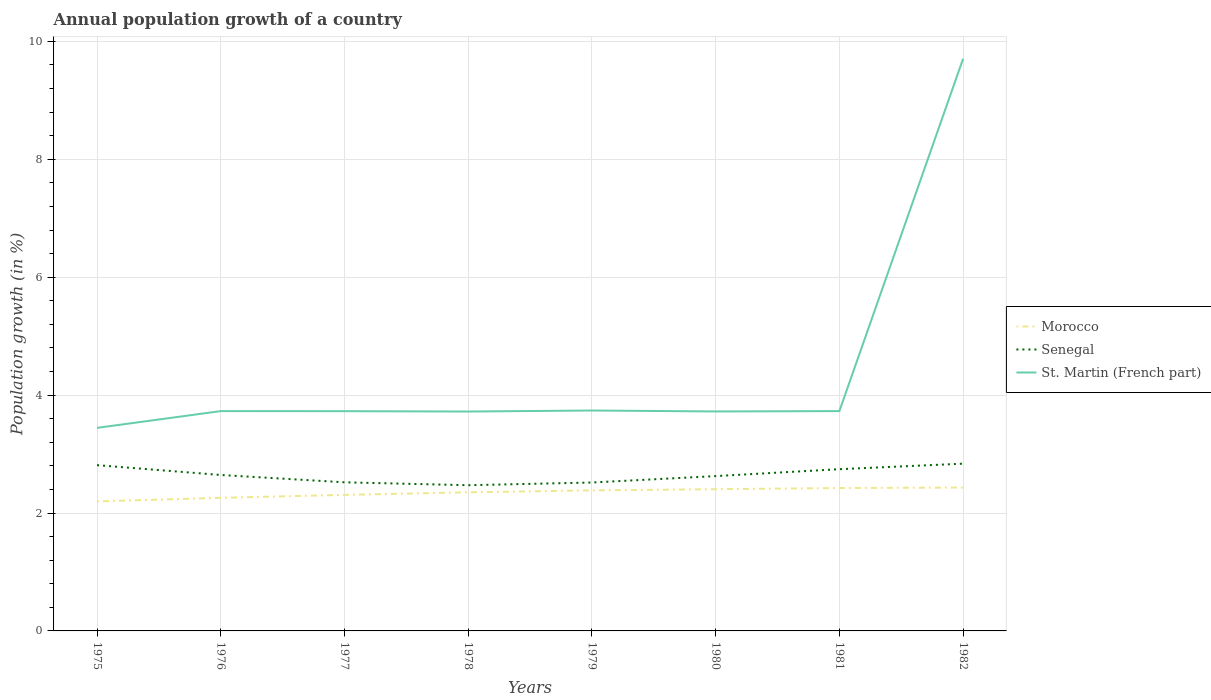How many different coloured lines are there?
Your answer should be compact. 3. Is the number of lines equal to the number of legend labels?
Your answer should be compact. Yes. Across all years, what is the maximum annual population growth in Senegal?
Ensure brevity in your answer.  2.47. In which year was the annual population growth in Senegal maximum?
Offer a very short reply. 1978. What is the total annual population growth in Senegal in the graph?
Your response must be concise. -0.21. What is the difference between the highest and the second highest annual population growth in Morocco?
Offer a terse response. 0.24. Is the annual population growth in St. Martin (French part) strictly greater than the annual population growth in Senegal over the years?
Offer a very short reply. No. How many years are there in the graph?
Offer a terse response. 8. Does the graph contain any zero values?
Keep it short and to the point. No. Does the graph contain grids?
Give a very brief answer. Yes. Where does the legend appear in the graph?
Give a very brief answer. Center right. How many legend labels are there?
Provide a short and direct response. 3. What is the title of the graph?
Offer a terse response. Annual population growth of a country. What is the label or title of the Y-axis?
Your response must be concise. Population growth (in %). What is the Population growth (in %) of Morocco in 1975?
Offer a very short reply. 2.2. What is the Population growth (in %) in Senegal in 1975?
Ensure brevity in your answer.  2.81. What is the Population growth (in %) in St. Martin (French part) in 1975?
Your answer should be very brief. 3.44. What is the Population growth (in %) of Morocco in 1976?
Provide a short and direct response. 2.26. What is the Population growth (in %) of Senegal in 1976?
Ensure brevity in your answer.  2.65. What is the Population growth (in %) of St. Martin (French part) in 1976?
Keep it short and to the point. 3.73. What is the Population growth (in %) of Morocco in 1977?
Your answer should be compact. 2.31. What is the Population growth (in %) in Senegal in 1977?
Offer a very short reply. 2.52. What is the Population growth (in %) in St. Martin (French part) in 1977?
Your answer should be very brief. 3.73. What is the Population growth (in %) of Morocco in 1978?
Ensure brevity in your answer.  2.35. What is the Population growth (in %) of Senegal in 1978?
Provide a short and direct response. 2.47. What is the Population growth (in %) in St. Martin (French part) in 1978?
Your response must be concise. 3.72. What is the Population growth (in %) of Morocco in 1979?
Your answer should be compact. 2.38. What is the Population growth (in %) in Senegal in 1979?
Provide a succinct answer. 2.52. What is the Population growth (in %) of St. Martin (French part) in 1979?
Offer a terse response. 3.74. What is the Population growth (in %) of Morocco in 1980?
Provide a short and direct response. 2.4. What is the Population growth (in %) in Senegal in 1980?
Ensure brevity in your answer.  2.63. What is the Population growth (in %) of St. Martin (French part) in 1980?
Keep it short and to the point. 3.72. What is the Population growth (in %) of Morocco in 1981?
Your response must be concise. 2.42. What is the Population growth (in %) in Senegal in 1981?
Keep it short and to the point. 2.74. What is the Population growth (in %) in St. Martin (French part) in 1981?
Provide a short and direct response. 3.73. What is the Population growth (in %) of Morocco in 1982?
Your response must be concise. 2.43. What is the Population growth (in %) of Senegal in 1982?
Your response must be concise. 2.84. What is the Population growth (in %) of St. Martin (French part) in 1982?
Provide a short and direct response. 9.71. Across all years, what is the maximum Population growth (in %) in Morocco?
Give a very brief answer. 2.43. Across all years, what is the maximum Population growth (in %) of Senegal?
Provide a succinct answer. 2.84. Across all years, what is the maximum Population growth (in %) in St. Martin (French part)?
Your answer should be very brief. 9.71. Across all years, what is the minimum Population growth (in %) of Morocco?
Ensure brevity in your answer.  2.2. Across all years, what is the minimum Population growth (in %) of Senegal?
Offer a terse response. 2.47. Across all years, what is the minimum Population growth (in %) in St. Martin (French part)?
Ensure brevity in your answer.  3.44. What is the total Population growth (in %) of Morocco in the graph?
Your answer should be compact. 18.76. What is the total Population growth (in %) of Senegal in the graph?
Offer a terse response. 21.17. What is the total Population growth (in %) of St. Martin (French part) in the graph?
Provide a short and direct response. 35.52. What is the difference between the Population growth (in %) of Morocco in 1975 and that in 1976?
Give a very brief answer. -0.06. What is the difference between the Population growth (in %) in Senegal in 1975 and that in 1976?
Your answer should be very brief. 0.17. What is the difference between the Population growth (in %) of St. Martin (French part) in 1975 and that in 1976?
Make the answer very short. -0.28. What is the difference between the Population growth (in %) of Morocco in 1975 and that in 1977?
Your answer should be very brief. -0.11. What is the difference between the Population growth (in %) of Senegal in 1975 and that in 1977?
Your response must be concise. 0.29. What is the difference between the Population growth (in %) in St. Martin (French part) in 1975 and that in 1977?
Make the answer very short. -0.28. What is the difference between the Population growth (in %) of Morocco in 1975 and that in 1978?
Your answer should be very brief. -0.15. What is the difference between the Population growth (in %) of Senegal in 1975 and that in 1978?
Give a very brief answer. 0.34. What is the difference between the Population growth (in %) of St. Martin (French part) in 1975 and that in 1978?
Make the answer very short. -0.28. What is the difference between the Population growth (in %) of Morocco in 1975 and that in 1979?
Offer a terse response. -0.19. What is the difference between the Population growth (in %) of Senegal in 1975 and that in 1979?
Your answer should be compact. 0.29. What is the difference between the Population growth (in %) in St. Martin (French part) in 1975 and that in 1979?
Provide a succinct answer. -0.29. What is the difference between the Population growth (in %) in Morocco in 1975 and that in 1980?
Provide a succinct answer. -0.21. What is the difference between the Population growth (in %) in Senegal in 1975 and that in 1980?
Your answer should be compact. 0.19. What is the difference between the Population growth (in %) of St. Martin (French part) in 1975 and that in 1980?
Offer a very short reply. -0.28. What is the difference between the Population growth (in %) of Morocco in 1975 and that in 1981?
Offer a very short reply. -0.23. What is the difference between the Population growth (in %) in Senegal in 1975 and that in 1981?
Your answer should be very brief. 0.07. What is the difference between the Population growth (in %) in St. Martin (French part) in 1975 and that in 1981?
Offer a terse response. -0.28. What is the difference between the Population growth (in %) in Morocco in 1975 and that in 1982?
Your answer should be very brief. -0.23. What is the difference between the Population growth (in %) of Senegal in 1975 and that in 1982?
Offer a very short reply. -0.03. What is the difference between the Population growth (in %) in St. Martin (French part) in 1975 and that in 1982?
Provide a short and direct response. -6.26. What is the difference between the Population growth (in %) of Morocco in 1976 and that in 1977?
Your response must be concise. -0.05. What is the difference between the Population growth (in %) in Senegal in 1976 and that in 1977?
Your answer should be very brief. 0.12. What is the difference between the Population growth (in %) in St. Martin (French part) in 1976 and that in 1977?
Offer a very short reply. 0. What is the difference between the Population growth (in %) of Morocco in 1976 and that in 1978?
Your answer should be compact. -0.09. What is the difference between the Population growth (in %) of Senegal in 1976 and that in 1978?
Provide a succinct answer. 0.17. What is the difference between the Population growth (in %) in St. Martin (French part) in 1976 and that in 1978?
Keep it short and to the point. 0.01. What is the difference between the Population growth (in %) in Morocco in 1976 and that in 1979?
Give a very brief answer. -0.13. What is the difference between the Population growth (in %) in Senegal in 1976 and that in 1979?
Offer a terse response. 0.13. What is the difference between the Population growth (in %) in St. Martin (French part) in 1976 and that in 1979?
Provide a succinct answer. -0.01. What is the difference between the Population growth (in %) in Morocco in 1976 and that in 1980?
Give a very brief answer. -0.15. What is the difference between the Population growth (in %) of Senegal in 1976 and that in 1980?
Make the answer very short. 0.02. What is the difference between the Population growth (in %) of St. Martin (French part) in 1976 and that in 1980?
Your answer should be very brief. 0.01. What is the difference between the Population growth (in %) of Morocco in 1976 and that in 1981?
Provide a succinct answer. -0.17. What is the difference between the Population growth (in %) in Senegal in 1976 and that in 1981?
Offer a very short reply. -0.1. What is the difference between the Population growth (in %) of St. Martin (French part) in 1976 and that in 1981?
Your answer should be compact. -0. What is the difference between the Population growth (in %) in Morocco in 1976 and that in 1982?
Ensure brevity in your answer.  -0.17. What is the difference between the Population growth (in %) of Senegal in 1976 and that in 1982?
Keep it short and to the point. -0.19. What is the difference between the Population growth (in %) in St. Martin (French part) in 1976 and that in 1982?
Give a very brief answer. -5.98. What is the difference between the Population growth (in %) of Morocco in 1977 and that in 1978?
Your response must be concise. -0.04. What is the difference between the Population growth (in %) of Senegal in 1977 and that in 1978?
Give a very brief answer. 0.05. What is the difference between the Population growth (in %) of St. Martin (French part) in 1977 and that in 1978?
Your answer should be compact. 0.01. What is the difference between the Population growth (in %) of Morocco in 1977 and that in 1979?
Keep it short and to the point. -0.08. What is the difference between the Population growth (in %) in Senegal in 1977 and that in 1979?
Offer a very short reply. 0. What is the difference between the Population growth (in %) of St. Martin (French part) in 1977 and that in 1979?
Give a very brief answer. -0.01. What is the difference between the Population growth (in %) in Morocco in 1977 and that in 1980?
Ensure brevity in your answer.  -0.1. What is the difference between the Population growth (in %) in Senegal in 1977 and that in 1980?
Your answer should be very brief. -0.11. What is the difference between the Population growth (in %) in St. Martin (French part) in 1977 and that in 1980?
Make the answer very short. 0. What is the difference between the Population growth (in %) of Morocco in 1977 and that in 1981?
Ensure brevity in your answer.  -0.12. What is the difference between the Population growth (in %) of Senegal in 1977 and that in 1981?
Keep it short and to the point. -0.22. What is the difference between the Population growth (in %) in St. Martin (French part) in 1977 and that in 1981?
Offer a terse response. -0. What is the difference between the Population growth (in %) of Morocco in 1977 and that in 1982?
Your answer should be very brief. -0.12. What is the difference between the Population growth (in %) of Senegal in 1977 and that in 1982?
Keep it short and to the point. -0.32. What is the difference between the Population growth (in %) in St. Martin (French part) in 1977 and that in 1982?
Your answer should be very brief. -5.98. What is the difference between the Population growth (in %) of Morocco in 1978 and that in 1979?
Keep it short and to the point. -0.03. What is the difference between the Population growth (in %) of Senegal in 1978 and that in 1979?
Offer a very short reply. -0.05. What is the difference between the Population growth (in %) in St. Martin (French part) in 1978 and that in 1979?
Make the answer very short. -0.02. What is the difference between the Population growth (in %) in Morocco in 1978 and that in 1980?
Ensure brevity in your answer.  -0.05. What is the difference between the Population growth (in %) in Senegal in 1978 and that in 1980?
Offer a terse response. -0.15. What is the difference between the Population growth (in %) in St. Martin (French part) in 1978 and that in 1980?
Ensure brevity in your answer.  -0. What is the difference between the Population growth (in %) in Morocco in 1978 and that in 1981?
Your response must be concise. -0.07. What is the difference between the Population growth (in %) in Senegal in 1978 and that in 1981?
Keep it short and to the point. -0.27. What is the difference between the Population growth (in %) of St. Martin (French part) in 1978 and that in 1981?
Ensure brevity in your answer.  -0.01. What is the difference between the Population growth (in %) of Morocco in 1978 and that in 1982?
Keep it short and to the point. -0.08. What is the difference between the Population growth (in %) of Senegal in 1978 and that in 1982?
Your answer should be very brief. -0.37. What is the difference between the Population growth (in %) of St. Martin (French part) in 1978 and that in 1982?
Your answer should be compact. -5.98. What is the difference between the Population growth (in %) of Morocco in 1979 and that in 1980?
Offer a very short reply. -0.02. What is the difference between the Population growth (in %) of Senegal in 1979 and that in 1980?
Provide a succinct answer. -0.11. What is the difference between the Population growth (in %) of St. Martin (French part) in 1979 and that in 1980?
Ensure brevity in your answer.  0.02. What is the difference between the Population growth (in %) in Morocco in 1979 and that in 1981?
Provide a succinct answer. -0.04. What is the difference between the Population growth (in %) in Senegal in 1979 and that in 1981?
Provide a short and direct response. -0.23. What is the difference between the Population growth (in %) in St. Martin (French part) in 1979 and that in 1981?
Your answer should be very brief. 0.01. What is the difference between the Population growth (in %) in Morocco in 1979 and that in 1982?
Your answer should be compact. -0.05. What is the difference between the Population growth (in %) in Senegal in 1979 and that in 1982?
Provide a succinct answer. -0.32. What is the difference between the Population growth (in %) in St. Martin (French part) in 1979 and that in 1982?
Your answer should be very brief. -5.97. What is the difference between the Population growth (in %) of Morocco in 1980 and that in 1981?
Offer a terse response. -0.02. What is the difference between the Population growth (in %) of Senegal in 1980 and that in 1981?
Provide a succinct answer. -0.12. What is the difference between the Population growth (in %) in St. Martin (French part) in 1980 and that in 1981?
Ensure brevity in your answer.  -0.01. What is the difference between the Population growth (in %) in Morocco in 1980 and that in 1982?
Ensure brevity in your answer.  -0.03. What is the difference between the Population growth (in %) in Senegal in 1980 and that in 1982?
Offer a very short reply. -0.21. What is the difference between the Population growth (in %) in St. Martin (French part) in 1980 and that in 1982?
Offer a terse response. -5.98. What is the difference between the Population growth (in %) of Morocco in 1981 and that in 1982?
Make the answer very short. -0.01. What is the difference between the Population growth (in %) of Senegal in 1981 and that in 1982?
Your response must be concise. -0.09. What is the difference between the Population growth (in %) of St. Martin (French part) in 1981 and that in 1982?
Your response must be concise. -5.98. What is the difference between the Population growth (in %) of Morocco in 1975 and the Population growth (in %) of Senegal in 1976?
Your response must be concise. -0.45. What is the difference between the Population growth (in %) of Morocco in 1975 and the Population growth (in %) of St. Martin (French part) in 1976?
Provide a short and direct response. -1.53. What is the difference between the Population growth (in %) in Senegal in 1975 and the Population growth (in %) in St. Martin (French part) in 1976?
Give a very brief answer. -0.92. What is the difference between the Population growth (in %) of Morocco in 1975 and the Population growth (in %) of Senegal in 1977?
Offer a very short reply. -0.32. What is the difference between the Population growth (in %) of Morocco in 1975 and the Population growth (in %) of St. Martin (French part) in 1977?
Make the answer very short. -1.53. What is the difference between the Population growth (in %) of Senegal in 1975 and the Population growth (in %) of St. Martin (French part) in 1977?
Provide a short and direct response. -0.92. What is the difference between the Population growth (in %) of Morocco in 1975 and the Population growth (in %) of Senegal in 1978?
Offer a very short reply. -0.27. What is the difference between the Population growth (in %) in Morocco in 1975 and the Population growth (in %) in St. Martin (French part) in 1978?
Make the answer very short. -1.52. What is the difference between the Population growth (in %) of Senegal in 1975 and the Population growth (in %) of St. Martin (French part) in 1978?
Make the answer very short. -0.91. What is the difference between the Population growth (in %) in Morocco in 1975 and the Population growth (in %) in Senegal in 1979?
Keep it short and to the point. -0.32. What is the difference between the Population growth (in %) in Morocco in 1975 and the Population growth (in %) in St. Martin (French part) in 1979?
Give a very brief answer. -1.54. What is the difference between the Population growth (in %) in Senegal in 1975 and the Population growth (in %) in St. Martin (French part) in 1979?
Give a very brief answer. -0.93. What is the difference between the Population growth (in %) in Morocco in 1975 and the Population growth (in %) in Senegal in 1980?
Provide a succinct answer. -0.43. What is the difference between the Population growth (in %) of Morocco in 1975 and the Population growth (in %) of St. Martin (French part) in 1980?
Keep it short and to the point. -1.53. What is the difference between the Population growth (in %) in Senegal in 1975 and the Population growth (in %) in St. Martin (French part) in 1980?
Your response must be concise. -0.91. What is the difference between the Population growth (in %) of Morocco in 1975 and the Population growth (in %) of Senegal in 1981?
Ensure brevity in your answer.  -0.55. What is the difference between the Population growth (in %) in Morocco in 1975 and the Population growth (in %) in St. Martin (French part) in 1981?
Give a very brief answer. -1.53. What is the difference between the Population growth (in %) in Senegal in 1975 and the Population growth (in %) in St. Martin (French part) in 1981?
Provide a succinct answer. -0.92. What is the difference between the Population growth (in %) of Morocco in 1975 and the Population growth (in %) of Senegal in 1982?
Offer a terse response. -0.64. What is the difference between the Population growth (in %) of Morocco in 1975 and the Population growth (in %) of St. Martin (French part) in 1982?
Provide a short and direct response. -7.51. What is the difference between the Population growth (in %) in Senegal in 1975 and the Population growth (in %) in St. Martin (French part) in 1982?
Offer a very short reply. -6.89. What is the difference between the Population growth (in %) of Morocco in 1976 and the Population growth (in %) of Senegal in 1977?
Give a very brief answer. -0.26. What is the difference between the Population growth (in %) in Morocco in 1976 and the Population growth (in %) in St. Martin (French part) in 1977?
Give a very brief answer. -1.47. What is the difference between the Population growth (in %) in Senegal in 1976 and the Population growth (in %) in St. Martin (French part) in 1977?
Your answer should be very brief. -1.08. What is the difference between the Population growth (in %) of Morocco in 1976 and the Population growth (in %) of Senegal in 1978?
Provide a succinct answer. -0.21. What is the difference between the Population growth (in %) in Morocco in 1976 and the Population growth (in %) in St. Martin (French part) in 1978?
Keep it short and to the point. -1.46. What is the difference between the Population growth (in %) in Senegal in 1976 and the Population growth (in %) in St. Martin (French part) in 1978?
Offer a terse response. -1.08. What is the difference between the Population growth (in %) of Morocco in 1976 and the Population growth (in %) of Senegal in 1979?
Give a very brief answer. -0.26. What is the difference between the Population growth (in %) in Morocco in 1976 and the Population growth (in %) in St. Martin (French part) in 1979?
Provide a succinct answer. -1.48. What is the difference between the Population growth (in %) of Senegal in 1976 and the Population growth (in %) of St. Martin (French part) in 1979?
Your response must be concise. -1.09. What is the difference between the Population growth (in %) in Morocco in 1976 and the Population growth (in %) in Senegal in 1980?
Offer a terse response. -0.37. What is the difference between the Population growth (in %) in Morocco in 1976 and the Population growth (in %) in St. Martin (French part) in 1980?
Offer a very short reply. -1.46. What is the difference between the Population growth (in %) of Senegal in 1976 and the Population growth (in %) of St. Martin (French part) in 1980?
Offer a very short reply. -1.08. What is the difference between the Population growth (in %) in Morocco in 1976 and the Population growth (in %) in Senegal in 1981?
Offer a very short reply. -0.49. What is the difference between the Population growth (in %) in Morocco in 1976 and the Population growth (in %) in St. Martin (French part) in 1981?
Offer a terse response. -1.47. What is the difference between the Population growth (in %) in Senegal in 1976 and the Population growth (in %) in St. Martin (French part) in 1981?
Make the answer very short. -1.08. What is the difference between the Population growth (in %) in Morocco in 1976 and the Population growth (in %) in Senegal in 1982?
Ensure brevity in your answer.  -0.58. What is the difference between the Population growth (in %) of Morocco in 1976 and the Population growth (in %) of St. Martin (French part) in 1982?
Keep it short and to the point. -7.45. What is the difference between the Population growth (in %) in Senegal in 1976 and the Population growth (in %) in St. Martin (French part) in 1982?
Give a very brief answer. -7.06. What is the difference between the Population growth (in %) of Morocco in 1977 and the Population growth (in %) of Senegal in 1978?
Your answer should be very brief. -0.16. What is the difference between the Population growth (in %) of Morocco in 1977 and the Population growth (in %) of St. Martin (French part) in 1978?
Your answer should be very brief. -1.41. What is the difference between the Population growth (in %) of Senegal in 1977 and the Population growth (in %) of St. Martin (French part) in 1978?
Provide a short and direct response. -1.2. What is the difference between the Population growth (in %) of Morocco in 1977 and the Population growth (in %) of Senegal in 1979?
Your answer should be compact. -0.21. What is the difference between the Population growth (in %) in Morocco in 1977 and the Population growth (in %) in St. Martin (French part) in 1979?
Make the answer very short. -1.43. What is the difference between the Population growth (in %) of Senegal in 1977 and the Population growth (in %) of St. Martin (French part) in 1979?
Give a very brief answer. -1.22. What is the difference between the Population growth (in %) in Morocco in 1977 and the Population growth (in %) in Senegal in 1980?
Ensure brevity in your answer.  -0.32. What is the difference between the Population growth (in %) of Morocco in 1977 and the Population growth (in %) of St. Martin (French part) in 1980?
Make the answer very short. -1.41. What is the difference between the Population growth (in %) in Senegal in 1977 and the Population growth (in %) in St. Martin (French part) in 1980?
Provide a succinct answer. -1.2. What is the difference between the Population growth (in %) of Morocco in 1977 and the Population growth (in %) of Senegal in 1981?
Ensure brevity in your answer.  -0.44. What is the difference between the Population growth (in %) in Morocco in 1977 and the Population growth (in %) in St. Martin (French part) in 1981?
Make the answer very short. -1.42. What is the difference between the Population growth (in %) in Senegal in 1977 and the Population growth (in %) in St. Martin (French part) in 1981?
Offer a terse response. -1.21. What is the difference between the Population growth (in %) of Morocco in 1977 and the Population growth (in %) of Senegal in 1982?
Give a very brief answer. -0.53. What is the difference between the Population growth (in %) in Morocco in 1977 and the Population growth (in %) in St. Martin (French part) in 1982?
Give a very brief answer. -7.4. What is the difference between the Population growth (in %) in Senegal in 1977 and the Population growth (in %) in St. Martin (French part) in 1982?
Give a very brief answer. -7.19. What is the difference between the Population growth (in %) of Morocco in 1978 and the Population growth (in %) of Senegal in 1979?
Ensure brevity in your answer.  -0.17. What is the difference between the Population growth (in %) of Morocco in 1978 and the Population growth (in %) of St. Martin (French part) in 1979?
Your answer should be compact. -1.39. What is the difference between the Population growth (in %) in Senegal in 1978 and the Population growth (in %) in St. Martin (French part) in 1979?
Your answer should be compact. -1.27. What is the difference between the Population growth (in %) of Morocco in 1978 and the Population growth (in %) of Senegal in 1980?
Provide a short and direct response. -0.27. What is the difference between the Population growth (in %) of Morocco in 1978 and the Population growth (in %) of St. Martin (French part) in 1980?
Offer a terse response. -1.37. What is the difference between the Population growth (in %) of Senegal in 1978 and the Population growth (in %) of St. Martin (French part) in 1980?
Ensure brevity in your answer.  -1.25. What is the difference between the Population growth (in %) in Morocco in 1978 and the Population growth (in %) in Senegal in 1981?
Offer a very short reply. -0.39. What is the difference between the Population growth (in %) of Morocco in 1978 and the Population growth (in %) of St. Martin (French part) in 1981?
Make the answer very short. -1.38. What is the difference between the Population growth (in %) in Senegal in 1978 and the Population growth (in %) in St. Martin (French part) in 1981?
Give a very brief answer. -1.26. What is the difference between the Population growth (in %) of Morocco in 1978 and the Population growth (in %) of Senegal in 1982?
Offer a terse response. -0.49. What is the difference between the Population growth (in %) in Morocco in 1978 and the Population growth (in %) in St. Martin (French part) in 1982?
Provide a succinct answer. -7.36. What is the difference between the Population growth (in %) in Senegal in 1978 and the Population growth (in %) in St. Martin (French part) in 1982?
Give a very brief answer. -7.23. What is the difference between the Population growth (in %) in Morocco in 1979 and the Population growth (in %) in Senegal in 1980?
Offer a terse response. -0.24. What is the difference between the Population growth (in %) in Morocco in 1979 and the Population growth (in %) in St. Martin (French part) in 1980?
Offer a very short reply. -1.34. What is the difference between the Population growth (in %) in Senegal in 1979 and the Population growth (in %) in St. Martin (French part) in 1980?
Your response must be concise. -1.21. What is the difference between the Population growth (in %) of Morocco in 1979 and the Population growth (in %) of Senegal in 1981?
Your answer should be compact. -0.36. What is the difference between the Population growth (in %) of Morocco in 1979 and the Population growth (in %) of St. Martin (French part) in 1981?
Make the answer very short. -1.34. What is the difference between the Population growth (in %) in Senegal in 1979 and the Population growth (in %) in St. Martin (French part) in 1981?
Your answer should be very brief. -1.21. What is the difference between the Population growth (in %) in Morocco in 1979 and the Population growth (in %) in Senegal in 1982?
Offer a very short reply. -0.45. What is the difference between the Population growth (in %) in Morocco in 1979 and the Population growth (in %) in St. Martin (French part) in 1982?
Offer a terse response. -7.32. What is the difference between the Population growth (in %) of Senegal in 1979 and the Population growth (in %) of St. Martin (French part) in 1982?
Ensure brevity in your answer.  -7.19. What is the difference between the Population growth (in %) of Morocco in 1980 and the Population growth (in %) of Senegal in 1981?
Ensure brevity in your answer.  -0.34. What is the difference between the Population growth (in %) in Morocco in 1980 and the Population growth (in %) in St. Martin (French part) in 1981?
Offer a terse response. -1.32. What is the difference between the Population growth (in %) of Senegal in 1980 and the Population growth (in %) of St. Martin (French part) in 1981?
Give a very brief answer. -1.1. What is the difference between the Population growth (in %) in Morocco in 1980 and the Population growth (in %) in Senegal in 1982?
Offer a terse response. -0.43. What is the difference between the Population growth (in %) in Morocco in 1980 and the Population growth (in %) in St. Martin (French part) in 1982?
Provide a short and direct response. -7.3. What is the difference between the Population growth (in %) in Senegal in 1980 and the Population growth (in %) in St. Martin (French part) in 1982?
Give a very brief answer. -7.08. What is the difference between the Population growth (in %) in Morocco in 1981 and the Population growth (in %) in Senegal in 1982?
Make the answer very short. -0.41. What is the difference between the Population growth (in %) in Morocco in 1981 and the Population growth (in %) in St. Martin (French part) in 1982?
Keep it short and to the point. -7.28. What is the difference between the Population growth (in %) of Senegal in 1981 and the Population growth (in %) of St. Martin (French part) in 1982?
Your answer should be very brief. -6.96. What is the average Population growth (in %) in Morocco per year?
Give a very brief answer. 2.34. What is the average Population growth (in %) of Senegal per year?
Your answer should be compact. 2.65. What is the average Population growth (in %) in St. Martin (French part) per year?
Give a very brief answer. 4.44. In the year 1975, what is the difference between the Population growth (in %) of Morocco and Population growth (in %) of Senegal?
Your response must be concise. -0.61. In the year 1975, what is the difference between the Population growth (in %) of Morocco and Population growth (in %) of St. Martin (French part)?
Your answer should be compact. -1.25. In the year 1975, what is the difference between the Population growth (in %) of Senegal and Population growth (in %) of St. Martin (French part)?
Ensure brevity in your answer.  -0.63. In the year 1976, what is the difference between the Population growth (in %) in Morocco and Population growth (in %) in Senegal?
Provide a succinct answer. -0.39. In the year 1976, what is the difference between the Population growth (in %) of Morocco and Population growth (in %) of St. Martin (French part)?
Offer a very short reply. -1.47. In the year 1976, what is the difference between the Population growth (in %) of Senegal and Population growth (in %) of St. Martin (French part)?
Make the answer very short. -1.08. In the year 1977, what is the difference between the Population growth (in %) in Morocco and Population growth (in %) in Senegal?
Keep it short and to the point. -0.21. In the year 1977, what is the difference between the Population growth (in %) of Morocco and Population growth (in %) of St. Martin (French part)?
Your response must be concise. -1.42. In the year 1977, what is the difference between the Population growth (in %) of Senegal and Population growth (in %) of St. Martin (French part)?
Provide a short and direct response. -1.21. In the year 1978, what is the difference between the Population growth (in %) of Morocco and Population growth (in %) of Senegal?
Your response must be concise. -0.12. In the year 1978, what is the difference between the Population growth (in %) in Morocco and Population growth (in %) in St. Martin (French part)?
Your answer should be very brief. -1.37. In the year 1978, what is the difference between the Population growth (in %) in Senegal and Population growth (in %) in St. Martin (French part)?
Your answer should be very brief. -1.25. In the year 1979, what is the difference between the Population growth (in %) of Morocco and Population growth (in %) of Senegal?
Give a very brief answer. -0.13. In the year 1979, what is the difference between the Population growth (in %) in Morocco and Population growth (in %) in St. Martin (French part)?
Keep it short and to the point. -1.35. In the year 1979, what is the difference between the Population growth (in %) in Senegal and Population growth (in %) in St. Martin (French part)?
Your response must be concise. -1.22. In the year 1980, what is the difference between the Population growth (in %) of Morocco and Population growth (in %) of Senegal?
Offer a terse response. -0.22. In the year 1980, what is the difference between the Population growth (in %) in Morocco and Population growth (in %) in St. Martin (French part)?
Keep it short and to the point. -1.32. In the year 1980, what is the difference between the Population growth (in %) of Senegal and Population growth (in %) of St. Martin (French part)?
Keep it short and to the point. -1.1. In the year 1981, what is the difference between the Population growth (in %) in Morocco and Population growth (in %) in Senegal?
Provide a short and direct response. -0.32. In the year 1981, what is the difference between the Population growth (in %) of Morocco and Population growth (in %) of St. Martin (French part)?
Provide a succinct answer. -1.31. In the year 1981, what is the difference between the Population growth (in %) in Senegal and Population growth (in %) in St. Martin (French part)?
Ensure brevity in your answer.  -0.99. In the year 1982, what is the difference between the Population growth (in %) of Morocco and Population growth (in %) of Senegal?
Provide a short and direct response. -0.41. In the year 1982, what is the difference between the Population growth (in %) of Morocco and Population growth (in %) of St. Martin (French part)?
Ensure brevity in your answer.  -7.27. In the year 1982, what is the difference between the Population growth (in %) of Senegal and Population growth (in %) of St. Martin (French part)?
Give a very brief answer. -6.87. What is the ratio of the Population growth (in %) in Morocco in 1975 to that in 1976?
Make the answer very short. 0.97. What is the ratio of the Population growth (in %) in Senegal in 1975 to that in 1976?
Your answer should be compact. 1.06. What is the ratio of the Population growth (in %) of St. Martin (French part) in 1975 to that in 1976?
Your response must be concise. 0.92. What is the ratio of the Population growth (in %) of Morocco in 1975 to that in 1977?
Provide a short and direct response. 0.95. What is the ratio of the Population growth (in %) in Senegal in 1975 to that in 1977?
Provide a short and direct response. 1.12. What is the ratio of the Population growth (in %) in St. Martin (French part) in 1975 to that in 1977?
Your answer should be very brief. 0.92. What is the ratio of the Population growth (in %) of Morocco in 1975 to that in 1978?
Give a very brief answer. 0.93. What is the ratio of the Population growth (in %) in Senegal in 1975 to that in 1978?
Provide a short and direct response. 1.14. What is the ratio of the Population growth (in %) of St. Martin (French part) in 1975 to that in 1978?
Your response must be concise. 0.93. What is the ratio of the Population growth (in %) of Morocco in 1975 to that in 1979?
Ensure brevity in your answer.  0.92. What is the ratio of the Population growth (in %) in Senegal in 1975 to that in 1979?
Offer a very short reply. 1.12. What is the ratio of the Population growth (in %) in St. Martin (French part) in 1975 to that in 1979?
Provide a short and direct response. 0.92. What is the ratio of the Population growth (in %) in Morocco in 1975 to that in 1980?
Your answer should be compact. 0.91. What is the ratio of the Population growth (in %) in Senegal in 1975 to that in 1980?
Ensure brevity in your answer.  1.07. What is the ratio of the Population growth (in %) in St. Martin (French part) in 1975 to that in 1980?
Provide a succinct answer. 0.93. What is the ratio of the Population growth (in %) in Morocco in 1975 to that in 1981?
Provide a short and direct response. 0.91. What is the ratio of the Population growth (in %) of Senegal in 1975 to that in 1981?
Provide a succinct answer. 1.02. What is the ratio of the Population growth (in %) of St. Martin (French part) in 1975 to that in 1981?
Your answer should be compact. 0.92. What is the ratio of the Population growth (in %) in Morocco in 1975 to that in 1982?
Keep it short and to the point. 0.9. What is the ratio of the Population growth (in %) in St. Martin (French part) in 1975 to that in 1982?
Your answer should be compact. 0.35. What is the ratio of the Population growth (in %) in Morocco in 1976 to that in 1977?
Ensure brevity in your answer.  0.98. What is the ratio of the Population growth (in %) in Senegal in 1976 to that in 1977?
Make the answer very short. 1.05. What is the ratio of the Population growth (in %) of St. Martin (French part) in 1976 to that in 1977?
Your response must be concise. 1. What is the ratio of the Population growth (in %) of Morocco in 1976 to that in 1978?
Ensure brevity in your answer.  0.96. What is the ratio of the Population growth (in %) in Senegal in 1976 to that in 1978?
Keep it short and to the point. 1.07. What is the ratio of the Population growth (in %) of Morocco in 1976 to that in 1979?
Your answer should be compact. 0.95. What is the ratio of the Population growth (in %) of Senegal in 1976 to that in 1979?
Keep it short and to the point. 1.05. What is the ratio of the Population growth (in %) in Morocco in 1976 to that in 1980?
Offer a terse response. 0.94. What is the ratio of the Population growth (in %) in Senegal in 1976 to that in 1980?
Provide a succinct answer. 1.01. What is the ratio of the Population growth (in %) of Morocco in 1976 to that in 1981?
Give a very brief answer. 0.93. What is the ratio of the Population growth (in %) in Senegal in 1976 to that in 1981?
Keep it short and to the point. 0.96. What is the ratio of the Population growth (in %) of Morocco in 1976 to that in 1982?
Make the answer very short. 0.93. What is the ratio of the Population growth (in %) in Senegal in 1976 to that in 1982?
Offer a very short reply. 0.93. What is the ratio of the Population growth (in %) in St. Martin (French part) in 1976 to that in 1982?
Your answer should be very brief. 0.38. What is the ratio of the Population growth (in %) in Morocco in 1977 to that in 1978?
Your answer should be compact. 0.98. What is the ratio of the Population growth (in %) in Senegal in 1977 to that in 1978?
Provide a short and direct response. 1.02. What is the ratio of the Population growth (in %) of St. Martin (French part) in 1977 to that in 1978?
Offer a very short reply. 1. What is the ratio of the Population growth (in %) in Morocco in 1977 to that in 1979?
Provide a succinct answer. 0.97. What is the ratio of the Population growth (in %) in Senegal in 1977 to that in 1979?
Make the answer very short. 1. What is the ratio of the Population growth (in %) of St. Martin (French part) in 1977 to that in 1979?
Provide a short and direct response. 1. What is the ratio of the Population growth (in %) of Senegal in 1977 to that in 1980?
Provide a succinct answer. 0.96. What is the ratio of the Population growth (in %) in Morocco in 1977 to that in 1981?
Ensure brevity in your answer.  0.95. What is the ratio of the Population growth (in %) of Senegal in 1977 to that in 1981?
Give a very brief answer. 0.92. What is the ratio of the Population growth (in %) of St. Martin (French part) in 1977 to that in 1981?
Offer a terse response. 1. What is the ratio of the Population growth (in %) in Morocco in 1977 to that in 1982?
Give a very brief answer. 0.95. What is the ratio of the Population growth (in %) of Senegal in 1977 to that in 1982?
Ensure brevity in your answer.  0.89. What is the ratio of the Population growth (in %) in St. Martin (French part) in 1977 to that in 1982?
Keep it short and to the point. 0.38. What is the ratio of the Population growth (in %) of Morocco in 1978 to that in 1979?
Give a very brief answer. 0.99. What is the ratio of the Population growth (in %) of Senegal in 1978 to that in 1979?
Provide a short and direct response. 0.98. What is the ratio of the Population growth (in %) of Morocco in 1978 to that in 1980?
Offer a terse response. 0.98. What is the ratio of the Population growth (in %) of Senegal in 1978 to that in 1980?
Provide a succinct answer. 0.94. What is the ratio of the Population growth (in %) of Morocco in 1978 to that in 1981?
Make the answer very short. 0.97. What is the ratio of the Population growth (in %) in Senegal in 1978 to that in 1981?
Your response must be concise. 0.9. What is the ratio of the Population growth (in %) in Morocco in 1978 to that in 1982?
Offer a terse response. 0.97. What is the ratio of the Population growth (in %) in Senegal in 1978 to that in 1982?
Provide a succinct answer. 0.87. What is the ratio of the Population growth (in %) of St. Martin (French part) in 1978 to that in 1982?
Make the answer very short. 0.38. What is the ratio of the Population growth (in %) of Morocco in 1979 to that in 1980?
Keep it short and to the point. 0.99. What is the ratio of the Population growth (in %) of Senegal in 1979 to that in 1980?
Your answer should be very brief. 0.96. What is the ratio of the Population growth (in %) in St. Martin (French part) in 1979 to that in 1980?
Give a very brief answer. 1. What is the ratio of the Population growth (in %) of Morocco in 1979 to that in 1981?
Your response must be concise. 0.98. What is the ratio of the Population growth (in %) of Senegal in 1979 to that in 1981?
Your response must be concise. 0.92. What is the ratio of the Population growth (in %) of St. Martin (French part) in 1979 to that in 1981?
Provide a succinct answer. 1. What is the ratio of the Population growth (in %) of Morocco in 1979 to that in 1982?
Provide a short and direct response. 0.98. What is the ratio of the Population growth (in %) in Senegal in 1979 to that in 1982?
Provide a short and direct response. 0.89. What is the ratio of the Population growth (in %) in St. Martin (French part) in 1979 to that in 1982?
Provide a succinct answer. 0.39. What is the ratio of the Population growth (in %) in Senegal in 1980 to that in 1981?
Your answer should be very brief. 0.96. What is the ratio of the Population growth (in %) in Senegal in 1980 to that in 1982?
Give a very brief answer. 0.93. What is the ratio of the Population growth (in %) in St. Martin (French part) in 1980 to that in 1982?
Give a very brief answer. 0.38. What is the ratio of the Population growth (in %) in Morocco in 1981 to that in 1982?
Your answer should be very brief. 1. What is the ratio of the Population growth (in %) of Senegal in 1981 to that in 1982?
Ensure brevity in your answer.  0.97. What is the ratio of the Population growth (in %) in St. Martin (French part) in 1981 to that in 1982?
Ensure brevity in your answer.  0.38. What is the difference between the highest and the second highest Population growth (in %) of Morocco?
Provide a succinct answer. 0.01. What is the difference between the highest and the second highest Population growth (in %) in Senegal?
Keep it short and to the point. 0.03. What is the difference between the highest and the second highest Population growth (in %) of St. Martin (French part)?
Your answer should be compact. 5.97. What is the difference between the highest and the lowest Population growth (in %) of Morocco?
Offer a terse response. 0.23. What is the difference between the highest and the lowest Population growth (in %) in Senegal?
Your answer should be compact. 0.37. What is the difference between the highest and the lowest Population growth (in %) of St. Martin (French part)?
Your answer should be very brief. 6.26. 